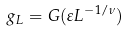Convert formula to latex. <formula><loc_0><loc_0><loc_500><loc_500>g _ { L } = G ( \varepsilon L ^ { - 1 / \nu } )</formula> 